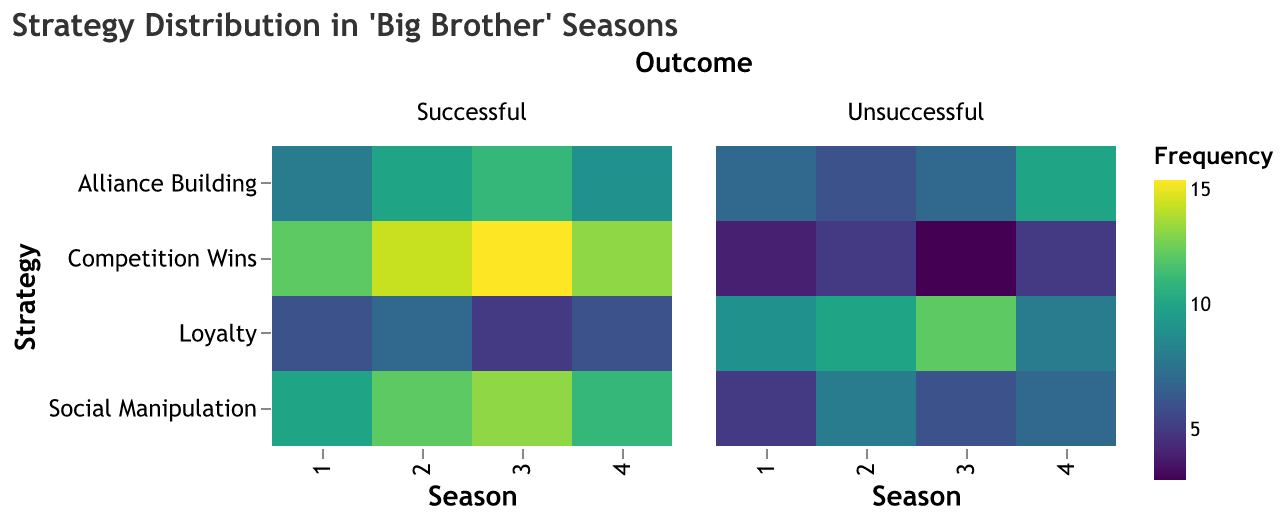what is the title of the heatmap? The title of the heatmap is displayed at the top of the figure, providing a summary of the data being visualized. In this case, the title reads "Strategy Distribution in 'Big Brother' Seasons."
Answer: Strategy Distribution in 'Big Brother' Seasons which strategy had the highest frequency of success in season 2? To determine this, locate the "Successful" facet for season 2 and compare the frequency values for each strategy. The strategy "Competition Wins" has the highest frequency of success with a value of 14.
Answer: Competition Wins what is the total frequency of 'Loyalty' strategies across all seasons for successful outcomes? Look at each season in the "Successful" facet and add the frequencies of the 'Loyalty' strategy: 6 (Season 1) + 7 (Season 2) + 5 (Season 3) + 6 (Season 4) = 24.
Answer: 24 which season had the lowest frequency of unsuccessful outcomes for 'Competition Wins'? Compare the 'Competition Wins' frequencies in the "Unsuccessful" facet across all seasons. Season 3 has the lowest frequency with a value of 3.
Answer: Season 3 how does the frequency of unsuccessful 'Alliance Building' strategies in season 4 compare to season 1? Find the 'Alliance Building' strategy in the "Unsuccessful" facet for both seasons: Season 4 has a frequency of 10, and Season 1 has a frequency of 7. This shows that Season 4 has a higher frequency of unsuccessful "Alliance Building" strategies.
Answer: Season 4 is higher which strategy generally shows the highest frequency of successful outcomes? In the "Successful" facet, compare the frequency values across all seasons for each strategy. 'Competition Wins' consistently shows the highest frequency values across all seasons – for example, it has frequencies of 12, 14, 15, and 13 in seasons 1, 2, 3, and 4 respectively.
Answer: Competition Wins is there a significant difference in the use of 'Social Manipulation' between successful and unsuccessful outcomes in season 3? Compare the frequencies of 'Social Manipulation' for both successful and unsuccessful outcomes in season 3. Successful outcome frequency is 13, while unsuccessful is 6, indicating a significant difference, with successful being much higher.
Answer: Yes, significant difference what is the average frequency of 'Alliance Building' strategies across all seasons for unsuccessful outcomes? Calculate the average by summing all 'Alliance Building' frequencies from the "Unsuccessful" facet and dividing by the number of seasons: (7 + 6 + 7 + 10) / 4 = 30 / 4 = 7.5.
Answer: 7.5 